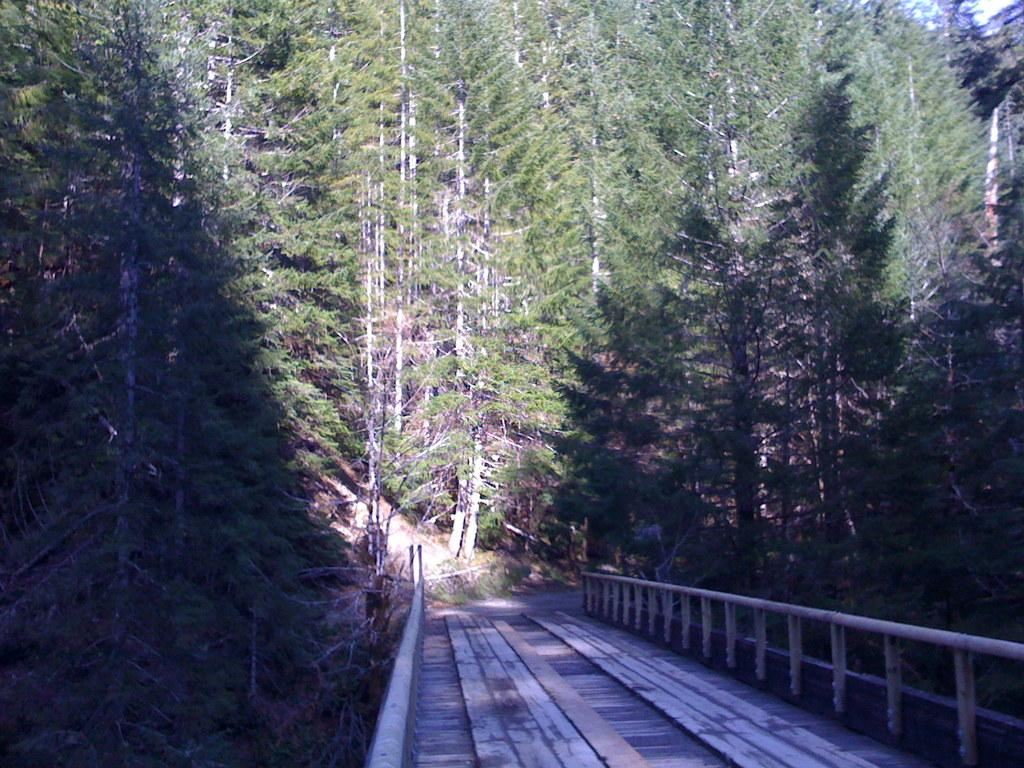What can be seen running through the image? There is a path in the image. What surrounds the path in the image? There is fencing on both sides of the path. What type of natural elements are present in the image? There are trees and plants in the image. What type of action is the carpenter performing in the image? There is no carpenter present in the image. Can you describe the bath that is visible in the image? There is no bath present in the image. 